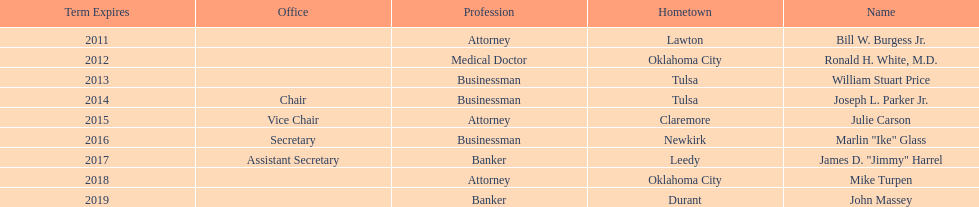Parse the table in full. {'header': ['Term Expires', 'Office', 'Profession', 'Hometown', 'Name'], 'rows': [['2011', '', 'Attorney', 'Lawton', 'Bill W. Burgess Jr.'], ['2012', '', 'Medical Doctor', 'Oklahoma City', 'Ronald H. White, M.D.'], ['2013', '', 'Businessman', 'Tulsa', 'William Stuart Price'], ['2014', 'Chair', 'Businessman', 'Tulsa', 'Joseph L. Parker Jr.'], ['2015', 'Vice Chair', 'Attorney', 'Claremore', 'Julie Carson'], ['2016', 'Secretary', 'Businessman', 'Newkirk', 'Marlin "Ike" Glass'], ['2017', 'Assistant Secretary', 'Banker', 'Leedy', 'James D. "Jimmy" Harrel'], ['2018', '', 'Attorney', 'Oklahoma City', 'Mike Turpen'], ['2019', '', 'Banker', 'Durant', 'John Massey']]} Which state regent is from the same hometown as ronald h. white, m.d.? Mike Turpen. 